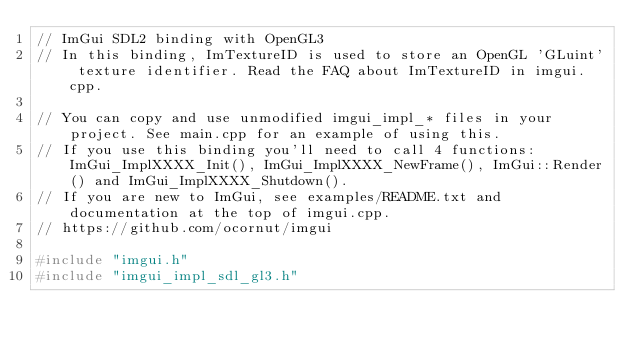Convert code to text. <code><loc_0><loc_0><loc_500><loc_500><_C++_>// ImGui SDL2 binding with OpenGL3
// In this binding, ImTextureID is used to store an OpenGL 'GLuint' texture identifier. Read the FAQ about ImTextureID in imgui.cpp.

// You can copy and use unmodified imgui_impl_* files in your project. See main.cpp for an example of using this.
// If you use this binding you'll need to call 4 functions: ImGui_ImplXXXX_Init(), ImGui_ImplXXXX_NewFrame(), ImGui::Render() and ImGui_ImplXXXX_Shutdown().
// If you are new to ImGui, see examples/README.txt and documentation at the top of imgui.cpp.
// https://github.com/ocornut/imgui

#include "imgui.h"
#include "imgui_impl_sdl_gl3.h"
</code> 